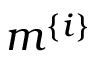Convert formula to latex. <formula><loc_0><loc_0><loc_500><loc_500>m ^ { \{ i \} }</formula> 